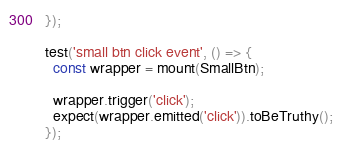<code> <loc_0><loc_0><loc_500><loc_500><_JavaScript_>});

test('small btn click event', () => {
  const wrapper = mount(SmallBtn);

  wrapper.trigger('click');
  expect(wrapper.emitted('click')).toBeTruthy();
});
</code> 